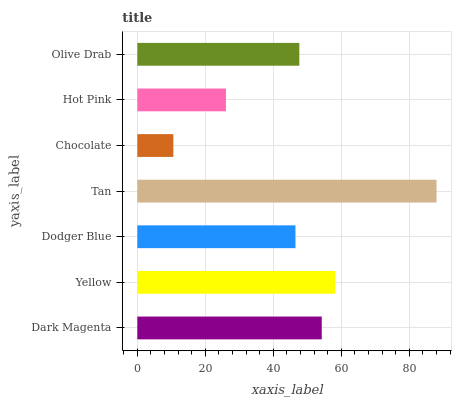Is Chocolate the minimum?
Answer yes or no. Yes. Is Tan the maximum?
Answer yes or no. Yes. Is Yellow the minimum?
Answer yes or no. No. Is Yellow the maximum?
Answer yes or no. No. Is Yellow greater than Dark Magenta?
Answer yes or no. Yes. Is Dark Magenta less than Yellow?
Answer yes or no. Yes. Is Dark Magenta greater than Yellow?
Answer yes or no. No. Is Yellow less than Dark Magenta?
Answer yes or no. No. Is Olive Drab the high median?
Answer yes or no. Yes. Is Olive Drab the low median?
Answer yes or no. Yes. Is Tan the high median?
Answer yes or no. No. Is Yellow the low median?
Answer yes or no. No. 